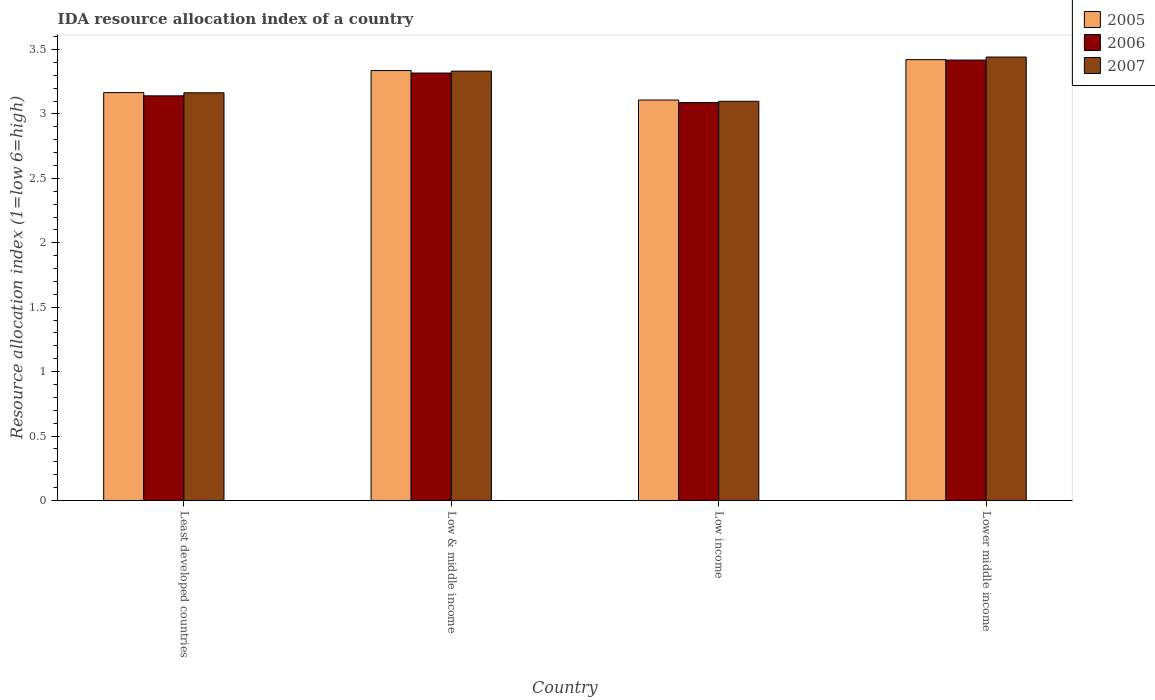Are the number of bars on each tick of the X-axis equal?
Make the answer very short. Yes. In how many cases, is the number of bars for a given country not equal to the number of legend labels?
Keep it short and to the point. 0. What is the IDA resource allocation index in 2007 in Low income?
Your answer should be very brief. 3.1. Across all countries, what is the maximum IDA resource allocation index in 2005?
Your answer should be very brief. 3.42. Across all countries, what is the minimum IDA resource allocation index in 2006?
Provide a short and direct response. 3.09. In which country was the IDA resource allocation index in 2005 maximum?
Your response must be concise. Lower middle income. What is the total IDA resource allocation index in 2006 in the graph?
Your answer should be compact. 12.97. What is the difference between the IDA resource allocation index in 2007 in Low income and that in Lower middle income?
Keep it short and to the point. -0.34. What is the difference between the IDA resource allocation index in 2007 in Low & middle income and the IDA resource allocation index in 2005 in Lower middle income?
Ensure brevity in your answer.  -0.09. What is the average IDA resource allocation index in 2005 per country?
Make the answer very short. 3.26. What is the difference between the IDA resource allocation index of/in 2005 and IDA resource allocation index of/in 2006 in Low income?
Keep it short and to the point. 0.02. In how many countries, is the IDA resource allocation index in 2005 greater than 3?
Provide a short and direct response. 4. What is the ratio of the IDA resource allocation index in 2007 in Least developed countries to that in Low & middle income?
Give a very brief answer. 0.95. What is the difference between the highest and the second highest IDA resource allocation index in 2005?
Make the answer very short. -0.08. What is the difference between the highest and the lowest IDA resource allocation index in 2005?
Make the answer very short. 0.31. In how many countries, is the IDA resource allocation index in 2005 greater than the average IDA resource allocation index in 2005 taken over all countries?
Keep it short and to the point. 2. What does the 3rd bar from the right in Least developed countries represents?
Provide a succinct answer. 2005. How many bars are there?
Keep it short and to the point. 12. How many countries are there in the graph?
Your answer should be very brief. 4. Are the values on the major ticks of Y-axis written in scientific E-notation?
Give a very brief answer. No. Does the graph contain any zero values?
Provide a short and direct response. No. How are the legend labels stacked?
Your response must be concise. Vertical. What is the title of the graph?
Your answer should be very brief. IDA resource allocation index of a country. Does "1970" appear as one of the legend labels in the graph?
Keep it short and to the point. No. What is the label or title of the Y-axis?
Offer a terse response. Resource allocation index (1=low 6=high). What is the Resource allocation index (1=low 6=high) in 2005 in Least developed countries?
Your response must be concise. 3.17. What is the Resource allocation index (1=low 6=high) in 2006 in Least developed countries?
Give a very brief answer. 3.14. What is the Resource allocation index (1=low 6=high) in 2007 in Least developed countries?
Offer a terse response. 3.16. What is the Resource allocation index (1=low 6=high) of 2005 in Low & middle income?
Provide a succinct answer. 3.34. What is the Resource allocation index (1=low 6=high) in 2006 in Low & middle income?
Keep it short and to the point. 3.32. What is the Resource allocation index (1=low 6=high) in 2007 in Low & middle income?
Your answer should be very brief. 3.33. What is the Resource allocation index (1=low 6=high) of 2005 in Low income?
Your answer should be very brief. 3.11. What is the Resource allocation index (1=low 6=high) of 2006 in Low income?
Ensure brevity in your answer.  3.09. What is the Resource allocation index (1=low 6=high) of 2007 in Low income?
Your response must be concise. 3.1. What is the Resource allocation index (1=low 6=high) in 2005 in Lower middle income?
Your answer should be very brief. 3.42. What is the Resource allocation index (1=low 6=high) of 2006 in Lower middle income?
Give a very brief answer. 3.42. What is the Resource allocation index (1=low 6=high) in 2007 in Lower middle income?
Provide a short and direct response. 3.44. Across all countries, what is the maximum Resource allocation index (1=low 6=high) in 2005?
Make the answer very short. 3.42. Across all countries, what is the maximum Resource allocation index (1=low 6=high) in 2006?
Offer a very short reply. 3.42. Across all countries, what is the maximum Resource allocation index (1=low 6=high) of 2007?
Offer a terse response. 3.44. Across all countries, what is the minimum Resource allocation index (1=low 6=high) in 2005?
Your response must be concise. 3.11. Across all countries, what is the minimum Resource allocation index (1=low 6=high) in 2006?
Make the answer very short. 3.09. Across all countries, what is the minimum Resource allocation index (1=low 6=high) of 2007?
Provide a short and direct response. 3.1. What is the total Resource allocation index (1=low 6=high) in 2005 in the graph?
Give a very brief answer. 13.03. What is the total Resource allocation index (1=low 6=high) of 2006 in the graph?
Give a very brief answer. 12.97. What is the total Resource allocation index (1=low 6=high) in 2007 in the graph?
Give a very brief answer. 13.04. What is the difference between the Resource allocation index (1=low 6=high) of 2005 in Least developed countries and that in Low & middle income?
Ensure brevity in your answer.  -0.17. What is the difference between the Resource allocation index (1=low 6=high) in 2006 in Least developed countries and that in Low & middle income?
Offer a very short reply. -0.18. What is the difference between the Resource allocation index (1=low 6=high) in 2007 in Least developed countries and that in Low & middle income?
Keep it short and to the point. -0.17. What is the difference between the Resource allocation index (1=low 6=high) of 2005 in Least developed countries and that in Low income?
Offer a very short reply. 0.06. What is the difference between the Resource allocation index (1=low 6=high) of 2006 in Least developed countries and that in Low income?
Provide a short and direct response. 0.05. What is the difference between the Resource allocation index (1=low 6=high) in 2007 in Least developed countries and that in Low income?
Your response must be concise. 0.07. What is the difference between the Resource allocation index (1=low 6=high) of 2005 in Least developed countries and that in Lower middle income?
Your answer should be very brief. -0.26. What is the difference between the Resource allocation index (1=low 6=high) of 2006 in Least developed countries and that in Lower middle income?
Your answer should be compact. -0.28. What is the difference between the Resource allocation index (1=low 6=high) of 2007 in Least developed countries and that in Lower middle income?
Your response must be concise. -0.28. What is the difference between the Resource allocation index (1=low 6=high) of 2005 in Low & middle income and that in Low income?
Ensure brevity in your answer.  0.23. What is the difference between the Resource allocation index (1=low 6=high) of 2006 in Low & middle income and that in Low income?
Your answer should be very brief. 0.23. What is the difference between the Resource allocation index (1=low 6=high) in 2007 in Low & middle income and that in Low income?
Offer a terse response. 0.23. What is the difference between the Resource allocation index (1=low 6=high) of 2005 in Low & middle income and that in Lower middle income?
Your answer should be compact. -0.08. What is the difference between the Resource allocation index (1=low 6=high) in 2006 in Low & middle income and that in Lower middle income?
Your answer should be compact. -0.1. What is the difference between the Resource allocation index (1=low 6=high) in 2007 in Low & middle income and that in Lower middle income?
Your answer should be very brief. -0.11. What is the difference between the Resource allocation index (1=low 6=high) of 2005 in Low income and that in Lower middle income?
Provide a short and direct response. -0.31. What is the difference between the Resource allocation index (1=low 6=high) in 2006 in Low income and that in Lower middle income?
Give a very brief answer. -0.33. What is the difference between the Resource allocation index (1=low 6=high) of 2007 in Low income and that in Lower middle income?
Ensure brevity in your answer.  -0.34. What is the difference between the Resource allocation index (1=low 6=high) of 2005 in Least developed countries and the Resource allocation index (1=low 6=high) of 2006 in Low & middle income?
Keep it short and to the point. -0.15. What is the difference between the Resource allocation index (1=low 6=high) in 2005 in Least developed countries and the Resource allocation index (1=low 6=high) in 2007 in Low & middle income?
Your response must be concise. -0.17. What is the difference between the Resource allocation index (1=low 6=high) of 2006 in Least developed countries and the Resource allocation index (1=low 6=high) of 2007 in Low & middle income?
Your answer should be compact. -0.19. What is the difference between the Resource allocation index (1=low 6=high) in 2005 in Least developed countries and the Resource allocation index (1=low 6=high) in 2006 in Low income?
Your answer should be compact. 0.08. What is the difference between the Resource allocation index (1=low 6=high) of 2005 in Least developed countries and the Resource allocation index (1=low 6=high) of 2007 in Low income?
Offer a very short reply. 0.07. What is the difference between the Resource allocation index (1=low 6=high) of 2006 in Least developed countries and the Resource allocation index (1=low 6=high) of 2007 in Low income?
Provide a succinct answer. 0.04. What is the difference between the Resource allocation index (1=low 6=high) of 2005 in Least developed countries and the Resource allocation index (1=low 6=high) of 2006 in Lower middle income?
Offer a very short reply. -0.25. What is the difference between the Resource allocation index (1=low 6=high) of 2005 in Least developed countries and the Resource allocation index (1=low 6=high) of 2007 in Lower middle income?
Provide a short and direct response. -0.28. What is the difference between the Resource allocation index (1=low 6=high) in 2006 in Least developed countries and the Resource allocation index (1=low 6=high) in 2007 in Lower middle income?
Give a very brief answer. -0.3. What is the difference between the Resource allocation index (1=low 6=high) of 2005 in Low & middle income and the Resource allocation index (1=low 6=high) of 2006 in Low income?
Offer a terse response. 0.25. What is the difference between the Resource allocation index (1=low 6=high) in 2005 in Low & middle income and the Resource allocation index (1=low 6=high) in 2007 in Low income?
Make the answer very short. 0.24. What is the difference between the Resource allocation index (1=low 6=high) in 2006 in Low & middle income and the Resource allocation index (1=low 6=high) in 2007 in Low income?
Your answer should be very brief. 0.22. What is the difference between the Resource allocation index (1=low 6=high) in 2005 in Low & middle income and the Resource allocation index (1=low 6=high) in 2006 in Lower middle income?
Give a very brief answer. -0.08. What is the difference between the Resource allocation index (1=low 6=high) in 2005 in Low & middle income and the Resource allocation index (1=low 6=high) in 2007 in Lower middle income?
Ensure brevity in your answer.  -0.1. What is the difference between the Resource allocation index (1=low 6=high) in 2006 in Low & middle income and the Resource allocation index (1=low 6=high) in 2007 in Lower middle income?
Keep it short and to the point. -0.12. What is the difference between the Resource allocation index (1=low 6=high) of 2005 in Low income and the Resource allocation index (1=low 6=high) of 2006 in Lower middle income?
Keep it short and to the point. -0.31. What is the difference between the Resource allocation index (1=low 6=high) of 2005 in Low income and the Resource allocation index (1=low 6=high) of 2007 in Lower middle income?
Ensure brevity in your answer.  -0.33. What is the difference between the Resource allocation index (1=low 6=high) of 2006 in Low income and the Resource allocation index (1=low 6=high) of 2007 in Lower middle income?
Offer a very short reply. -0.35. What is the average Resource allocation index (1=low 6=high) in 2005 per country?
Your response must be concise. 3.26. What is the average Resource allocation index (1=low 6=high) of 2006 per country?
Offer a very short reply. 3.24. What is the average Resource allocation index (1=low 6=high) of 2007 per country?
Provide a succinct answer. 3.26. What is the difference between the Resource allocation index (1=low 6=high) of 2005 and Resource allocation index (1=low 6=high) of 2006 in Least developed countries?
Keep it short and to the point. 0.03. What is the difference between the Resource allocation index (1=low 6=high) in 2005 and Resource allocation index (1=low 6=high) in 2007 in Least developed countries?
Offer a terse response. 0. What is the difference between the Resource allocation index (1=low 6=high) of 2006 and Resource allocation index (1=low 6=high) of 2007 in Least developed countries?
Give a very brief answer. -0.02. What is the difference between the Resource allocation index (1=low 6=high) in 2005 and Resource allocation index (1=low 6=high) in 2006 in Low & middle income?
Make the answer very short. 0.02. What is the difference between the Resource allocation index (1=low 6=high) of 2005 and Resource allocation index (1=low 6=high) of 2007 in Low & middle income?
Your answer should be very brief. 0. What is the difference between the Resource allocation index (1=low 6=high) in 2006 and Resource allocation index (1=low 6=high) in 2007 in Low & middle income?
Your answer should be very brief. -0.01. What is the difference between the Resource allocation index (1=low 6=high) of 2005 and Resource allocation index (1=low 6=high) of 2006 in Low income?
Make the answer very short. 0.02. What is the difference between the Resource allocation index (1=low 6=high) in 2005 and Resource allocation index (1=low 6=high) in 2007 in Low income?
Give a very brief answer. 0.01. What is the difference between the Resource allocation index (1=low 6=high) of 2006 and Resource allocation index (1=low 6=high) of 2007 in Low income?
Offer a terse response. -0.01. What is the difference between the Resource allocation index (1=low 6=high) of 2005 and Resource allocation index (1=low 6=high) of 2006 in Lower middle income?
Keep it short and to the point. 0. What is the difference between the Resource allocation index (1=low 6=high) of 2005 and Resource allocation index (1=low 6=high) of 2007 in Lower middle income?
Your answer should be compact. -0.02. What is the difference between the Resource allocation index (1=low 6=high) of 2006 and Resource allocation index (1=low 6=high) of 2007 in Lower middle income?
Your response must be concise. -0.02. What is the ratio of the Resource allocation index (1=low 6=high) in 2005 in Least developed countries to that in Low & middle income?
Offer a very short reply. 0.95. What is the ratio of the Resource allocation index (1=low 6=high) in 2006 in Least developed countries to that in Low & middle income?
Make the answer very short. 0.95. What is the ratio of the Resource allocation index (1=low 6=high) in 2007 in Least developed countries to that in Low & middle income?
Offer a very short reply. 0.95. What is the ratio of the Resource allocation index (1=low 6=high) in 2005 in Least developed countries to that in Low income?
Keep it short and to the point. 1.02. What is the ratio of the Resource allocation index (1=low 6=high) in 2006 in Least developed countries to that in Low income?
Your answer should be very brief. 1.02. What is the ratio of the Resource allocation index (1=low 6=high) in 2007 in Least developed countries to that in Low income?
Provide a succinct answer. 1.02. What is the ratio of the Resource allocation index (1=low 6=high) of 2005 in Least developed countries to that in Lower middle income?
Your answer should be very brief. 0.93. What is the ratio of the Resource allocation index (1=low 6=high) in 2006 in Least developed countries to that in Lower middle income?
Offer a very short reply. 0.92. What is the ratio of the Resource allocation index (1=low 6=high) in 2007 in Least developed countries to that in Lower middle income?
Provide a short and direct response. 0.92. What is the ratio of the Resource allocation index (1=low 6=high) in 2005 in Low & middle income to that in Low income?
Provide a short and direct response. 1.07. What is the ratio of the Resource allocation index (1=low 6=high) of 2006 in Low & middle income to that in Low income?
Ensure brevity in your answer.  1.07. What is the ratio of the Resource allocation index (1=low 6=high) of 2007 in Low & middle income to that in Low income?
Your response must be concise. 1.08. What is the ratio of the Resource allocation index (1=low 6=high) of 2005 in Low & middle income to that in Lower middle income?
Your response must be concise. 0.98. What is the ratio of the Resource allocation index (1=low 6=high) in 2006 in Low & middle income to that in Lower middle income?
Your answer should be very brief. 0.97. What is the ratio of the Resource allocation index (1=low 6=high) in 2007 in Low & middle income to that in Lower middle income?
Give a very brief answer. 0.97. What is the ratio of the Resource allocation index (1=low 6=high) of 2005 in Low income to that in Lower middle income?
Ensure brevity in your answer.  0.91. What is the ratio of the Resource allocation index (1=low 6=high) in 2006 in Low income to that in Lower middle income?
Keep it short and to the point. 0.9. What is the ratio of the Resource allocation index (1=low 6=high) in 2007 in Low income to that in Lower middle income?
Provide a succinct answer. 0.9. What is the difference between the highest and the second highest Resource allocation index (1=low 6=high) in 2005?
Give a very brief answer. 0.08. What is the difference between the highest and the second highest Resource allocation index (1=low 6=high) in 2006?
Give a very brief answer. 0.1. What is the difference between the highest and the second highest Resource allocation index (1=low 6=high) of 2007?
Offer a very short reply. 0.11. What is the difference between the highest and the lowest Resource allocation index (1=low 6=high) in 2005?
Offer a terse response. 0.31. What is the difference between the highest and the lowest Resource allocation index (1=low 6=high) of 2006?
Your answer should be very brief. 0.33. What is the difference between the highest and the lowest Resource allocation index (1=low 6=high) in 2007?
Offer a terse response. 0.34. 